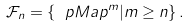<formula> <loc_0><loc_0><loc_500><loc_500>\mathcal { F } _ { n } = \left \{ \ p M a p ^ { m } | m \geq n \right \} .</formula> 